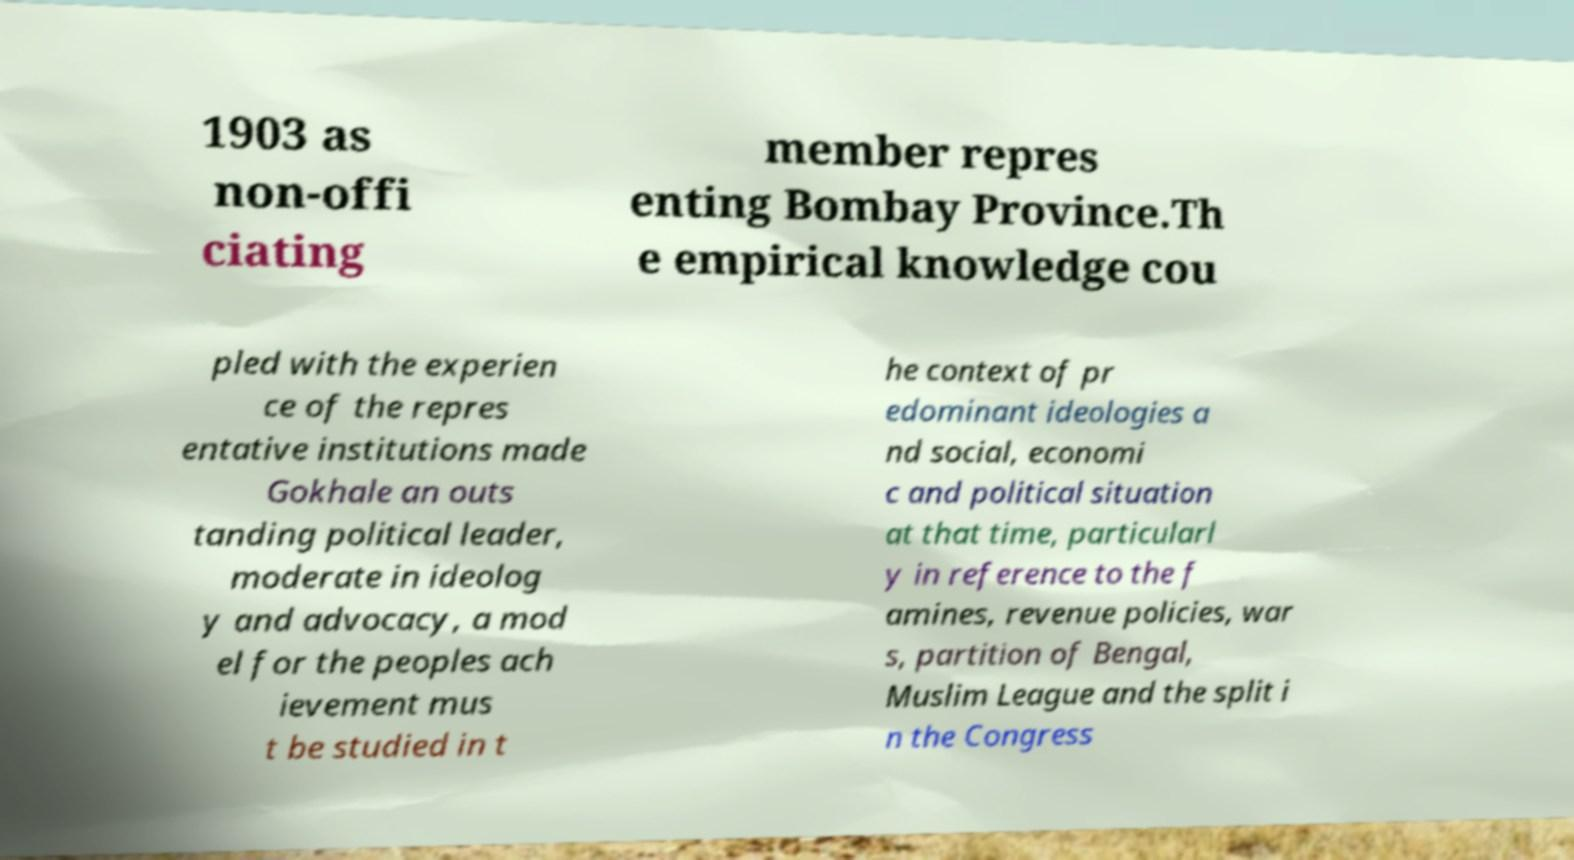Please read and relay the text visible in this image. What does it say? 1903 as non-offi ciating member repres enting Bombay Province.Th e empirical knowledge cou pled with the experien ce of the repres entative institutions made Gokhale an outs tanding political leader, moderate in ideolog y and advocacy, a mod el for the peoples ach ievement mus t be studied in t he context of pr edominant ideologies a nd social, economi c and political situation at that time, particularl y in reference to the f amines, revenue policies, war s, partition of Bengal, Muslim League and the split i n the Congress 